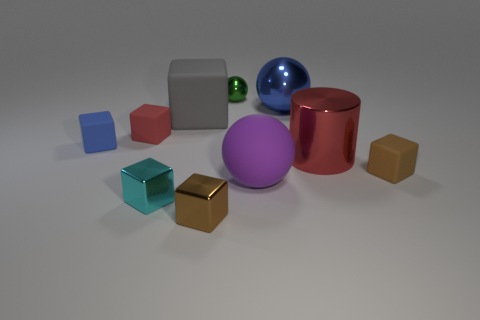What is the shape of the small matte object that is the same color as the big cylinder?
Your answer should be very brief. Cube. How many objects are both in front of the small green object and to the left of the small brown rubber object?
Give a very brief answer. 8. What number of brown shiny things have the same shape as the large gray thing?
Your answer should be very brief. 1. There is a large object that is in front of the tiny brown cube that is right of the red metal cylinder; what color is it?
Ensure brevity in your answer.  Purple. There is a small brown rubber object; is it the same shape as the blue object right of the tiny cyan thing?
Give a very brief answer. No. What material is the blue thing that is on the right side of the tiny metallic block on the right side of the large rubber thing that is behind the big purple object?
Your response must be concise. Metal. Is there a red shiny thing that has the same size as the cyan block?
Provide a short and direct response. No. There is a red thing that is the same material as the purple object; what is its size?
Give a very brief answer. Small. What is the shape of the brown rubber object?
Give a very brief answer. Cube. Do the small sphere and the brown block behind the small brown metal block have the same material?
Your response must be concise. No. 